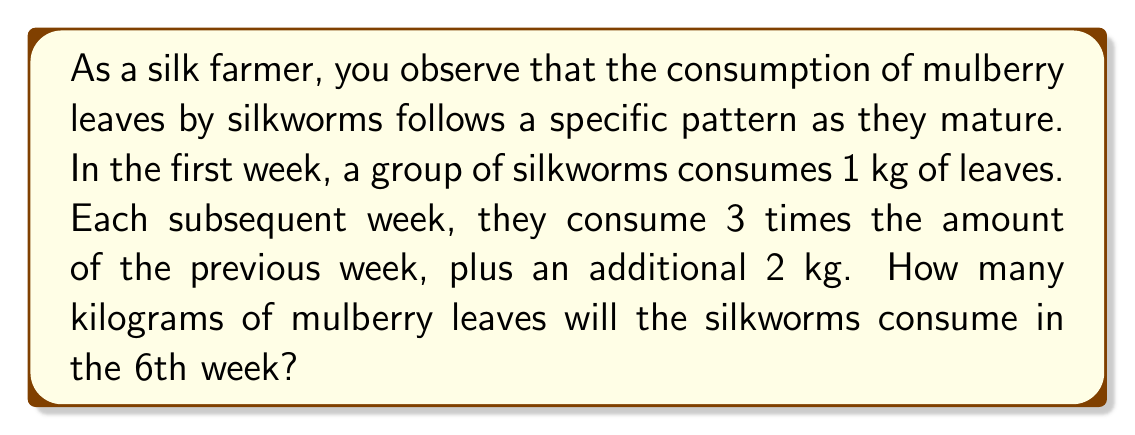Can you answer this question? Let's approach this step-by-step:

1) Let $a_n$ represent the amount of leaves consumed in week $n$.

2) We're given that $a_1 = 1$ kg (first week consumption).

3) The sequence follows the pattern: $a_n = 3a_{n-1} + 2$ for $n \geq 2$.

4) Let's calculate the consumption for each week:

   Week 1: $a_1 = 1$ kg
   Week 2: $a_2 = 3(1) + 2 = 5$ kg
   Week 3: $a_3 = 3(5) + 2 = 17$ kg
   Week 4: $a_4 = 3(17) + 2 = 53$ kg
   Week 5: $a_5 = 3(53) + 2 = 161$ kg
   Week 6: $a_6 = 3(161) + 2 = 485$ kg

5) Therefore, in the 6th week, the silkworms will consume 485 kg of mulberry leaves.

Alternatively, we can derive a general formula:

$$a_n = 3^{n-1} + 3^{n-2} \cdot 2 + 3^{n-3} \cdot 2 + ... + 3^1 \cdot 2 + 3^0 \cdot 2$$

This simplifies to:

$$a_n = 3^{n-1} + 2 \cdot \frac{3^{n-1} - 1}{2} = \frac{3^n + 1}{2}$$

For $n = 6$:

$$a_6 = \frac{3^6 + 1}{2} = \frac{729 + 1}{2} = 365$$

This confirms our step-by-step calculation.
Answer: 485 kg 